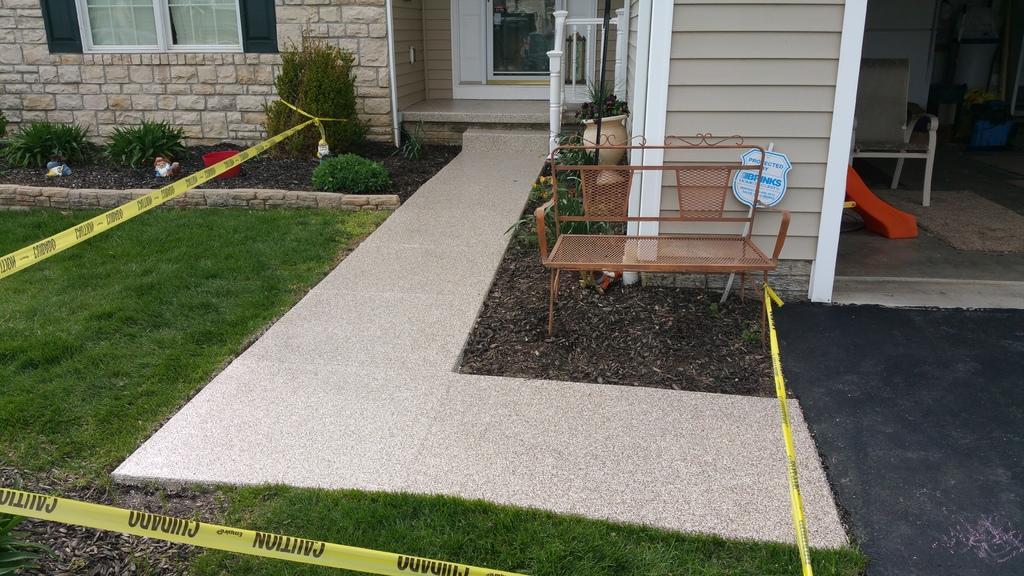Can you describe this image briefly? We can see caution tag,grass,bench and house plants. We can see wall,window and door. 